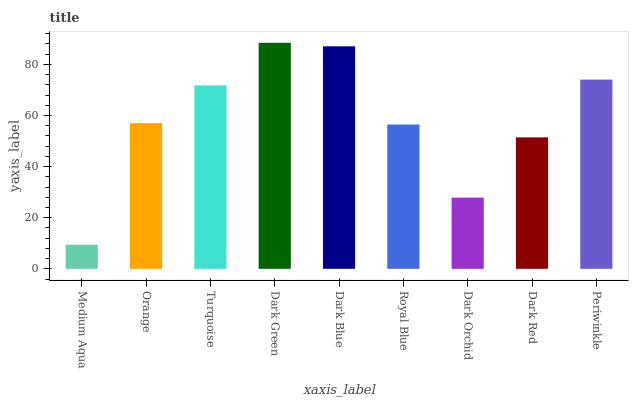Is Medium Aqua the minimum?
Answer yes or no. Yes. Is Dark Green the maximum?
Answer yes or no. Yes. Is Orange the minimum?
Answer yes or no. No. Is Orange the maximum?
Answer yes or no. No. Is Orange greater than Medium Aqua?
Answer yes or no. Yes. Is Medium Aqua less than Orange?
Answer yes or no. Yes. Is Medium Aqua greater than Orange?
Answer yes or no. No. Is Orange less than Medium Aqua?
Answer yes or no. No. Is Orange the high median?
Answer yes or no. Yes. Is Orange the low median?
Answer yes or no. Yes. Is Dark Green the high median?
Answer yes or no. No. Is Medium Aqua the low median?
Answer yes or no. No. 